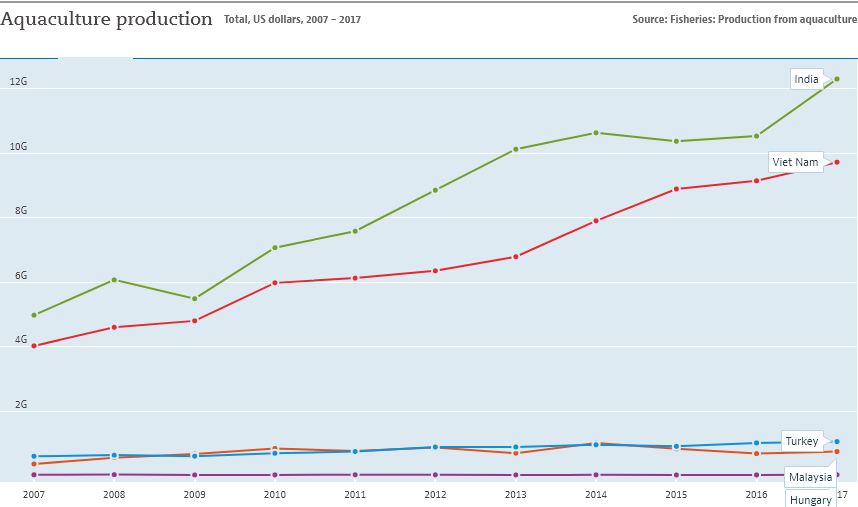Indicate a few pertinent items in this graphic. The sum of the bottom three countries in 2017 is not larger than India in 2017. The green line represents the country of India. 